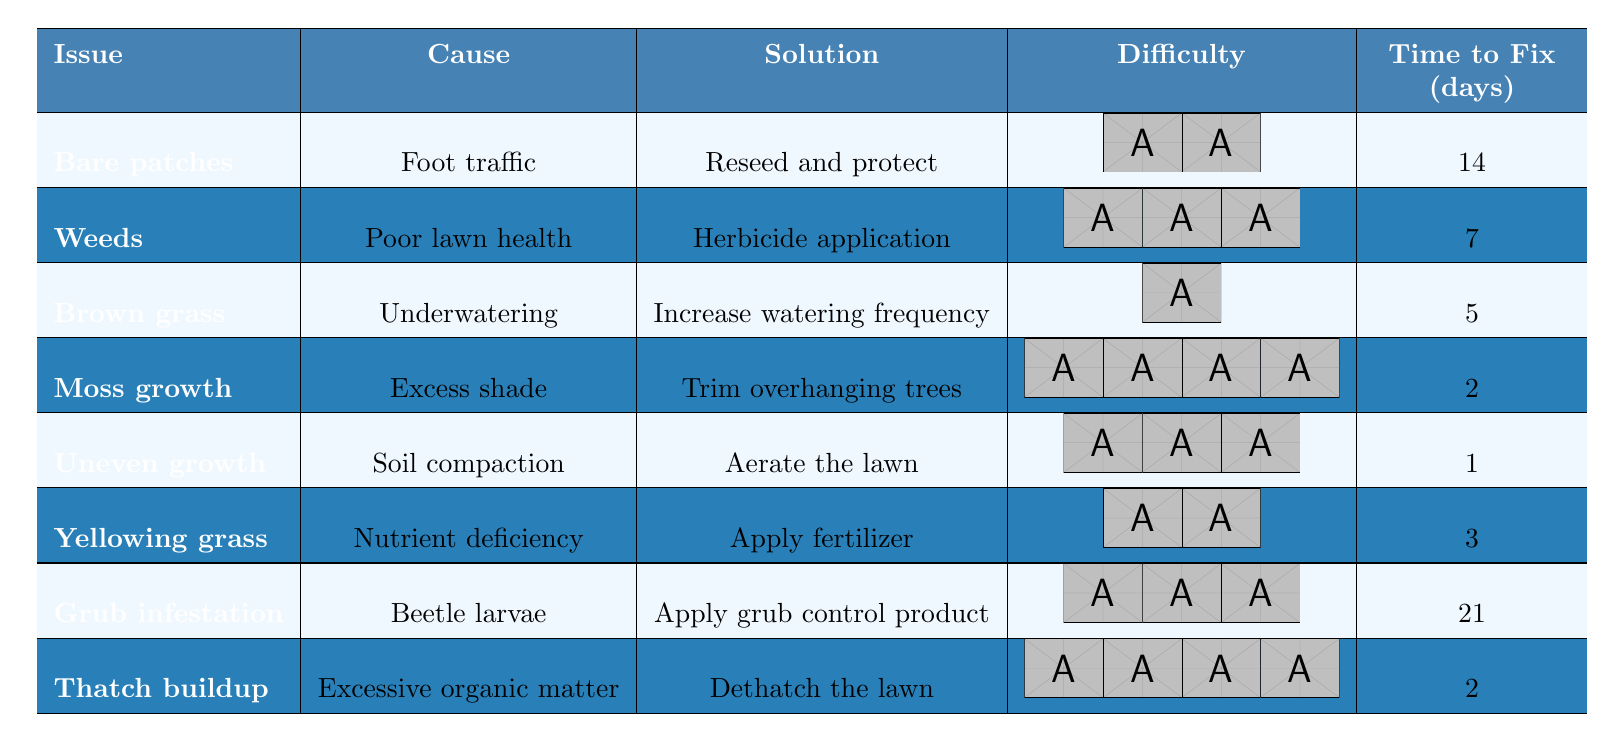What is the solution for bare patches? According to the table, the solution for bare patches is to reseed and protect the area.
Answer: Reseed and protect How many days does it take to fix brown grass? The table indicates that it takes 5 days to fix brown grass.
Answer: 5 days Is the cause of uneven growth soil compaction? The table states that the cause of uneven growth is indeed soil compaction.
Answer: Yes What is the total time to fix grub infestation and thatch buildup? From the table, grub infestation takes 21 days and thatch buildup takes 2 days. Adding these gives 21 + 2 = 23 days.
Answer: 23 days Which lawn issue takes the least time to fix? The table shows that uneven growth takes only 1 day to fix, which is the least time among all issues.
Answer: Uneven growth Does applying fertilizer have a higher difficulty rating than herbicide application? The difficulty rating for applying fertilizer is 2, while herbicide application has a rating of 3, hence applying fertilizer is easier.
Answer: No What is the average difficulty rating of all the lawn issues listed? To find the average, sum the difficulty ratings (2+3+1+4+3+2+3+4 = 22), then divide by the number of issues (8): 22/8 = 2.75.
Answer: 2.75 How many of the issues require a solution that takes more than 10 days to fix? Looking at the table, only grub infestation requires more than 10 days to fix (21 days). Thus, there is 1 issue.
Answer: 1 What is the maximum time it takes to fix any lawn issue according to the table? Grub infestation takes the longest at 21 days, which is the maximum time listed for any issue.
Answer: 21 days What solution should be applied in case of yellowing grass? The table specifies that to deal with yellowing grass, one should apply fertilizer.
Answer: Apply fertilizer 